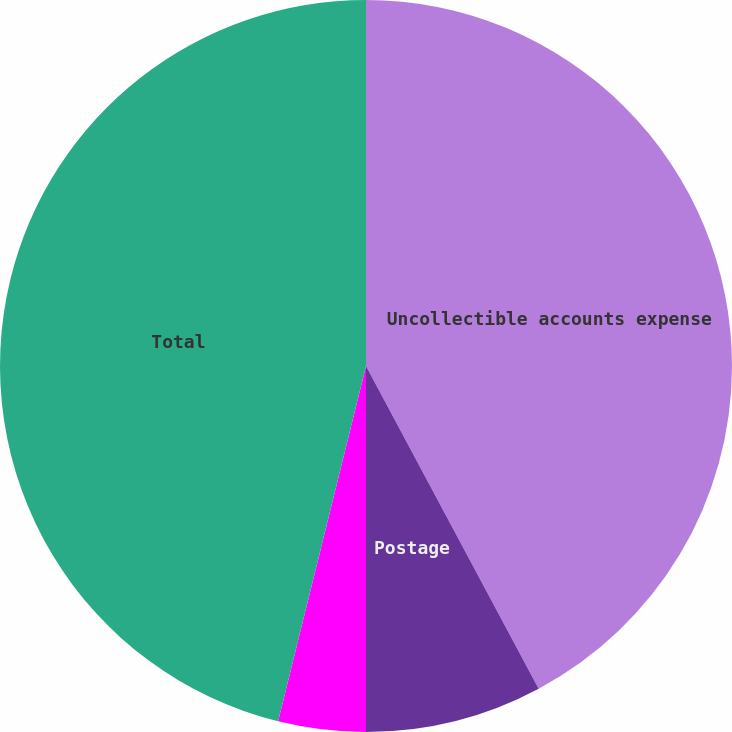Convert chart. <chart><loc_0><loc_0><loc_500><loc_500><pie_chart><fcel>Uncollectible accounts expense<fcel>Postage<fcel>Other<fcel>Total<nl><fcel>42.18%<fcel>7.82%<fcel>3.86%<fcel>46.14%<nl></chart> 